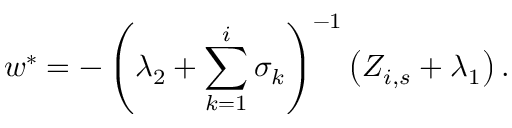<formula> <loc_0><loc_0><loc_500><loc_500>w ^ { \ast } = - \left ( \lambda _ { 2 } + \sum _ { k = 1 } ^ { i } \sigma _ { k } \right ) ^ { - 1 } \left ( Z _ { i , s } + \lambda _ { 1 } \right ) .</formula> 